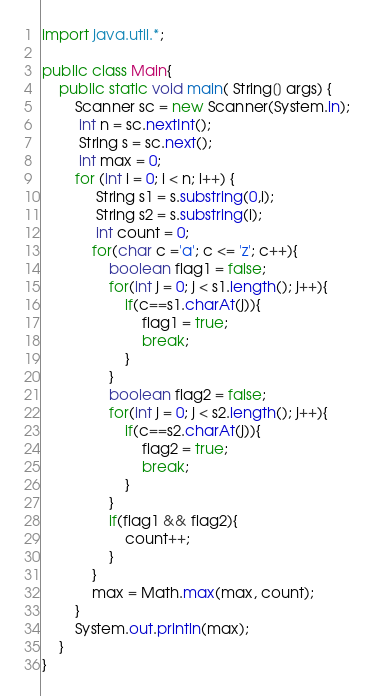<code> <loc_0><loc_0><loc_500><loc_500><_Java_>import java.util.*;

public class Main{
    public static void main( String[] args) {
        Scanner sc = new Scanner(System.in);
         int n = sc.nextInt();
         String s = sc.next();
         int max = 0;
        for (int i = 0; i < n; i++) {
             String s1 = s.substring(0,i);
             String s2 = s.substring(i);
             int count = 0;
            for(char c ='a'; c <= 'z'; c++){
                boolean flag1 = false;
                for(int j = 0; j < s1.length(); j++){
                    if(c==s1.charAt(j)){
                        flag1 = true;
                        break;
                    }
                }
                boolean flag2 = false;
                for(int j = 0; j < s2.length(); j++){
                    if(c==s2.charAt(j)){
                        flag2 = true;
                        break;
                    }
                }
                if(flag1 && flag2){
                    count++;
                }
            }
            max = Math.max(max, count);
        }   
        System.out.println(max);
    }
}</code> 